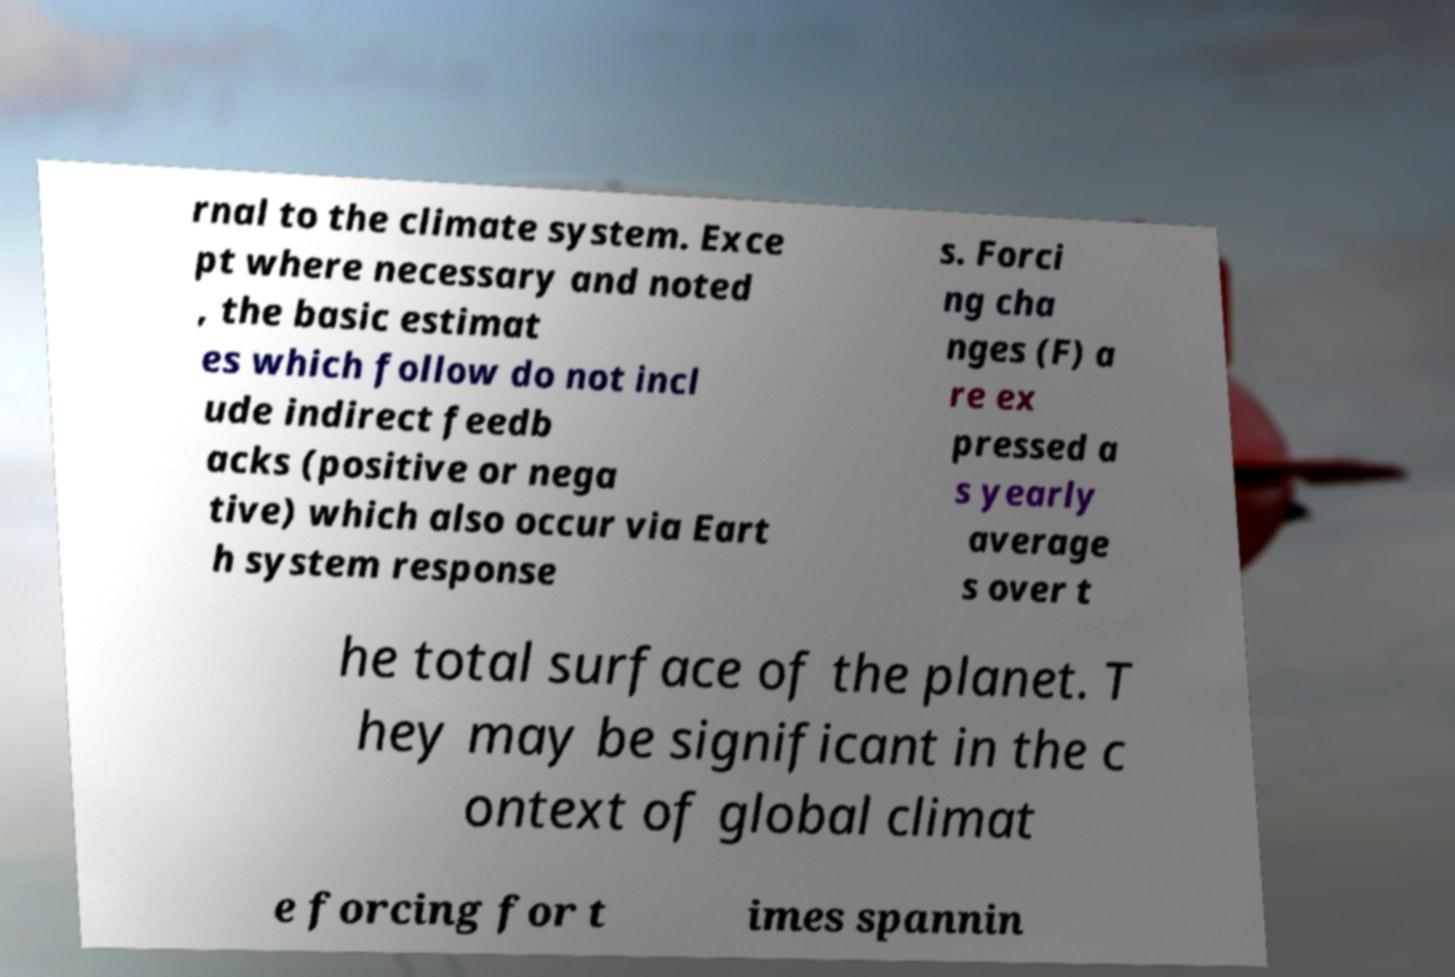Could you assist in decoding the text presented in this image and type it out clearly? rnal to the climate system. Exce pt where necessary and noted , the basic estimat es which follow do not incl ude indirect feedb acks (positive or nega tive) which also occur via Eart h system response s. Forci ng cha nges (F) a re ex pressed a s yearly average s over t he total surface of the planet. T hey may be significant in the c ontext of global climat e forcing for t imes spannin 